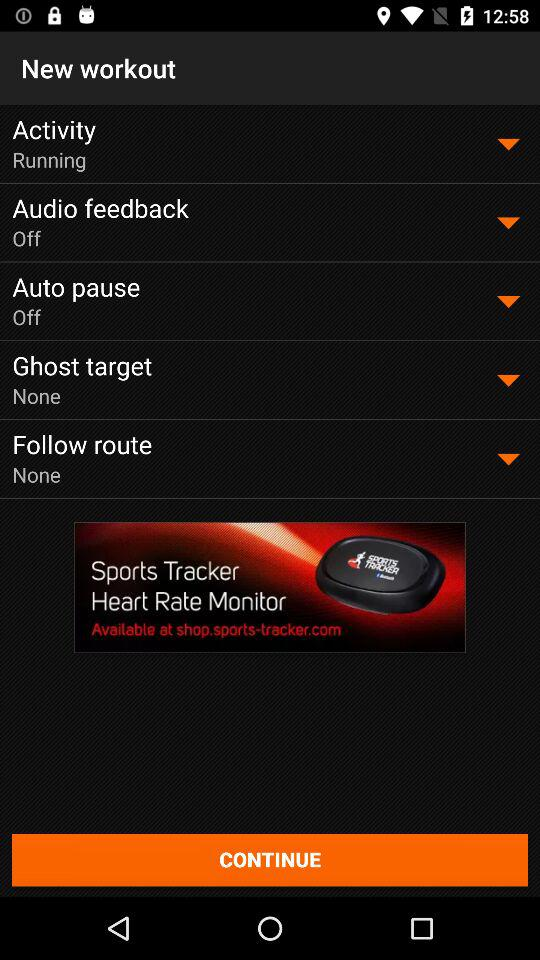What is the status of the auto pause setting? The status is off. 